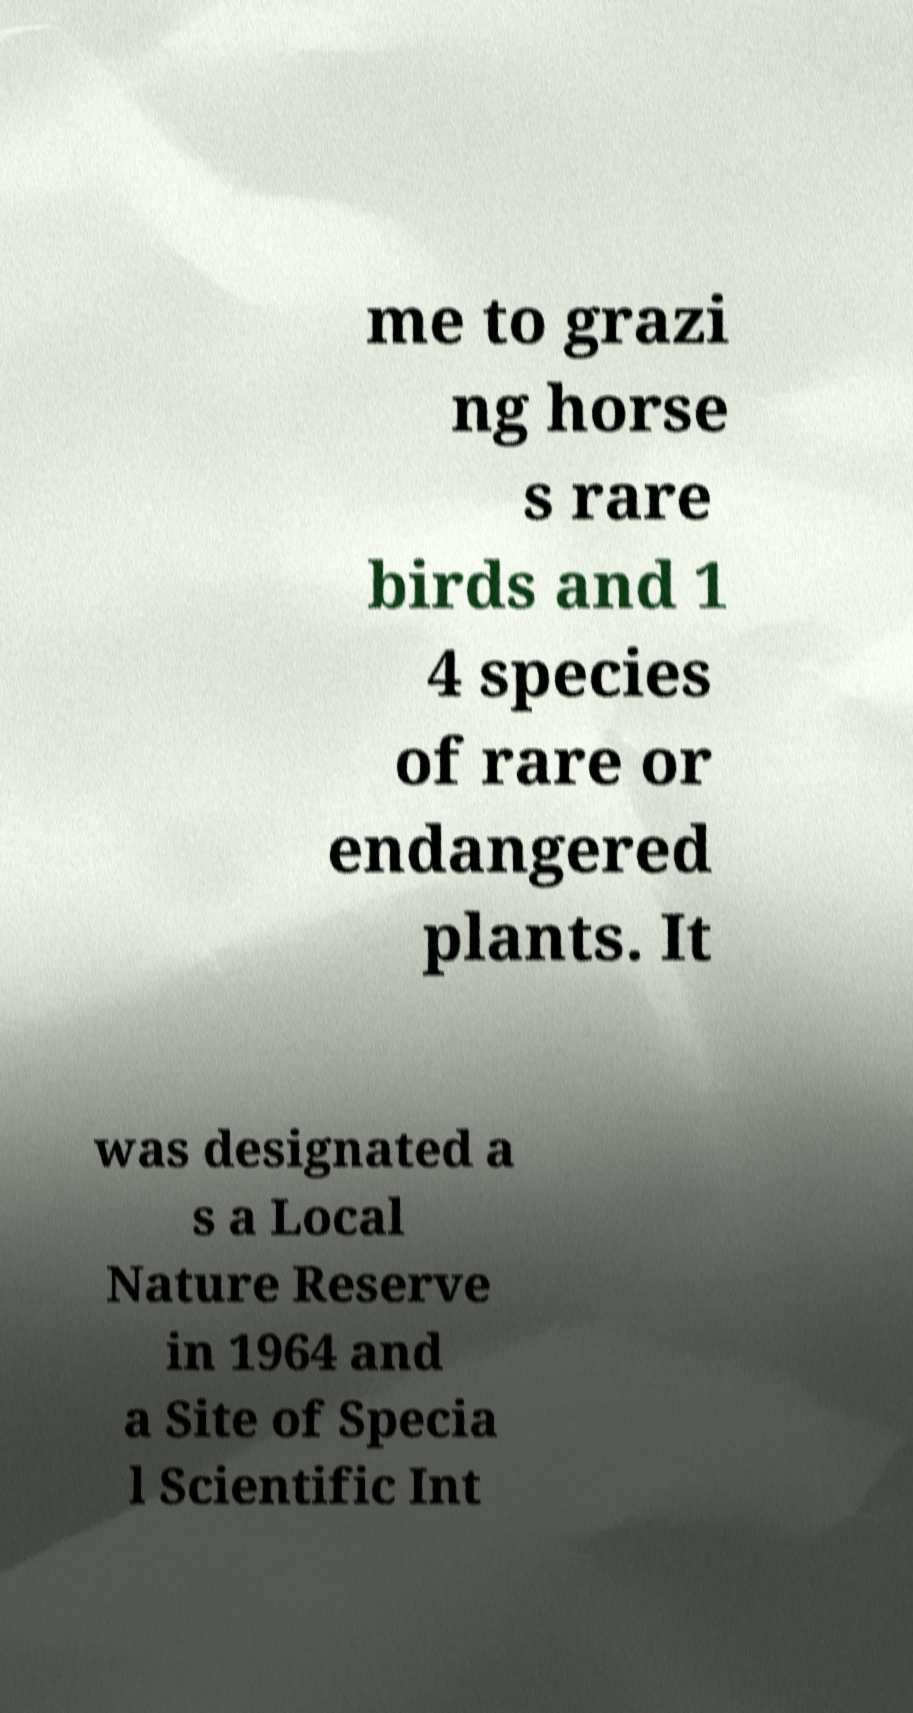Can you accurately transcribe the text from the provided image for me? me to grazi ng horse s rare birds and 1 4 species of rare or endangered plants. It was designated a s a Local Nature Reserve in 1964 and a Site of Specia l Scientific Int 